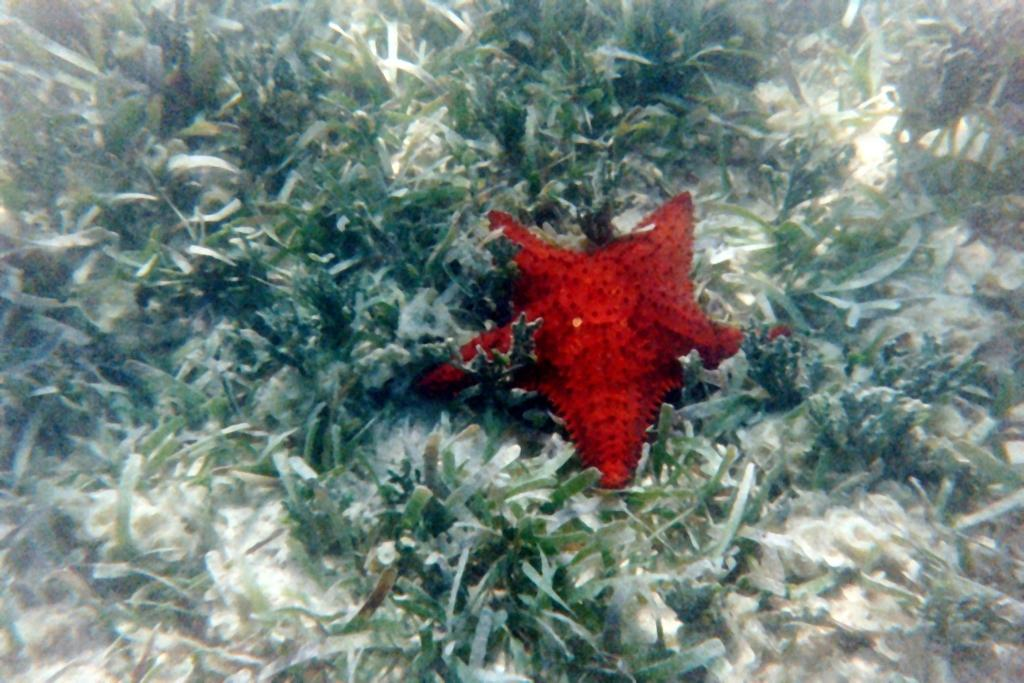What type of animal is in the image? There is a starfish in the image. What other elements can be seen in the image? There are aquatic plants in the image. What type of gate can be seen in the image? There is no gate present in the image; it features a starfish and aquatic plants. How does the starfish's temper affect the aquatic plants in the image? Starfish do not have a temper, as they are inanimate objects. Additionally, there is no interaction between the starfish and the aquatic plants in the image. 